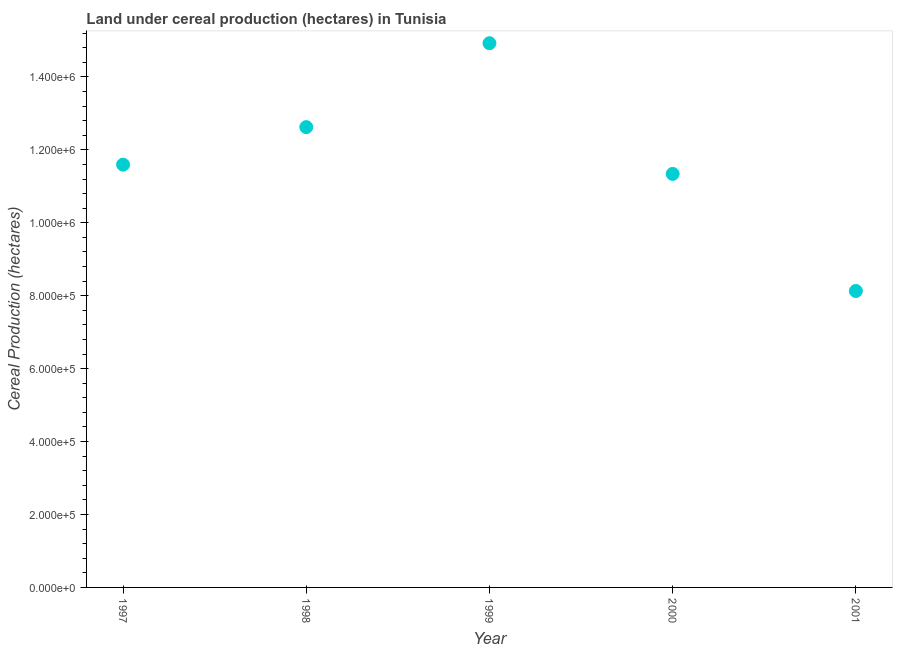What is the land under cereal production in 1999?
Offer a very short reply. 1.49e+06. Across all years, what is the maximum land under cereal production?
Offer a very short reply. 1.49e+06. Across all years, what is the minimum land under cereal production?
Ensure brevity in your answer.  8.13e+05. In which year was the land under cereal production minimum?
Provide a short and direct response. 2001. What is the sum of the land under cereal production?
Give a very brief answer. 5.86e+06. What is the difference between the land under cereal production in 2000 and 2001?
Provide a short and direct response. 3.21e+05. What is the average land under cereal production per year?
Make the answer very short. 1.17e+06. What is the median land under cereal production?
Make the answer very short. 1.16e+06. Do a majority of the years between 1999 and 2000 (inclusive) have land under cereal production greater than 1440000 hectares?
Ensure brevity in your answer.  No. What is the ratio of the land under cereal production in 1998 to that in 1999?
Offer a very short reply. 0.85. Is the difference between the land under cereal production in 1997 and 2000 greater than the difference between any two years?
Offer a very short reply. No. What is the difference between the highest and the second highest land under cereal production?
Your answer should be very brief. 2.30e+05. What is the difference between the highest and the lowest land under cereal production?
Your response must be concise. 6.79e+05. Does the land under cereal production monotonically increase over the years?
Offer a terse response. No. How many dotlines are there?
Ensure brevity in your answer.  1. What is the difference between two consecutive major ticks on the Y-axis?
Ensure brevity in your answer.  2.00e+05. Are the values on the major ticks of Y-axis written in scientific E-notation?
Provide a succinct answer. Yes. Does the graph contain any zero values?
Keep it short and to the point. No. What is the title of the graph?
Give a very brief answer. Land under cereal production (hectares) in Tunisia. What is the label or title of the Y-axis?
Give a very brief answer. Cereal Production (hectares). What is the Cereal Production (hectares) in 1997?
Give a very brief answer. 1.16e+06. What is the Cereal Production (hectares) in 1998?
Your answer should be compact. 1.26e+06. What is the Cereal Production (hectares) in 1999?
Your answer should be very brief. 1.49e+06. What is the Cereal Production (hectares) in 2000?
Provide a short and direct response. 1.13e+06. What is the Cereal Production (hectares) in 2001?
Ensure brevity in your answer.  8.13e+05. What is the difference between the Cereal Production (hectares) in 1997 and 1998?
Provide a succinct answer. -1.03e+05. What is the difference between the Cereal Production (hectares) in 1997 and 1999?
Offer a terse response. -3.33e+05. What is the difference between the Cereal Production (hectares) in 1997 and 2000?
Keep it short and to the point. 2.54e+04. What is the difference between the Cereal Production (hectares) in 1997 and 2001?
Provide a short and direct response. 3.46e+05. What is the difference between the Cereal Production (hectares) in 1998 and 1999?
Offer a very short reply. -2.30e+05. What is the difference between the Cereal Production (hectares) in 1998 and 2000?
Give a very brief answer. 1.28e+05. What is the difference between the Cereal Production (hectares) in 1998 and 2001?
Your answer should be very brief. 4.49e+05. What is the difference between the Cereal Production (hectares) in 1999 and 2000?
Your response must be concise. 3.58e+05. What is the difference between the Cereal Production (hectares) in 1999 and 2001?
Offer a terse response. 6.79e+05. What is the difference between the Cereal Production (hectares) in 2000 and 2001?
Keep it short and to the point. 3.21e+05. What is the ratio of the Cereal Production (hectares) in 1997 to that in 1998?
Provide a succinct answer. 0.92. What is the ratio of the Cereal Production (hectares) in 1997 to that in 1999?
Give a very brief answer. 0.78. What is the ratio of the Cereal Production (hectares) in 1997 to that in 2000?
Ensure brevity in your answer.  1.02. What is the ratio of the Cereal Production (hectares) in 1997 to that in 2001?
Offer a terse response. 1.43. What is the ratio of the Cereal Production (hectares) in 1998 to that in 1999?
Provide a succinct answer. 0.85. What is the ratio of the Cereal Production (hectares) in 1998 to that in 2000?
Provide a succinct answer. 1.11. What is the ratio of the Cereal Production (hectares) in 1998 to that in 2001?
Provide a short and direct response. 1.55. What is the ratio of the Cereal Production (hectares) in 1999 to that in 2000?
Offer a very short reply. 1.32. What is the ratio of the Cereal Production (hectares) in 1999 to that in 2001?
Keep it short and to the point. 1.84. What is the ratio of the Cereal Production (hectares) in 2000 to that in 2001?
Offer a very short reply. 1.4. 